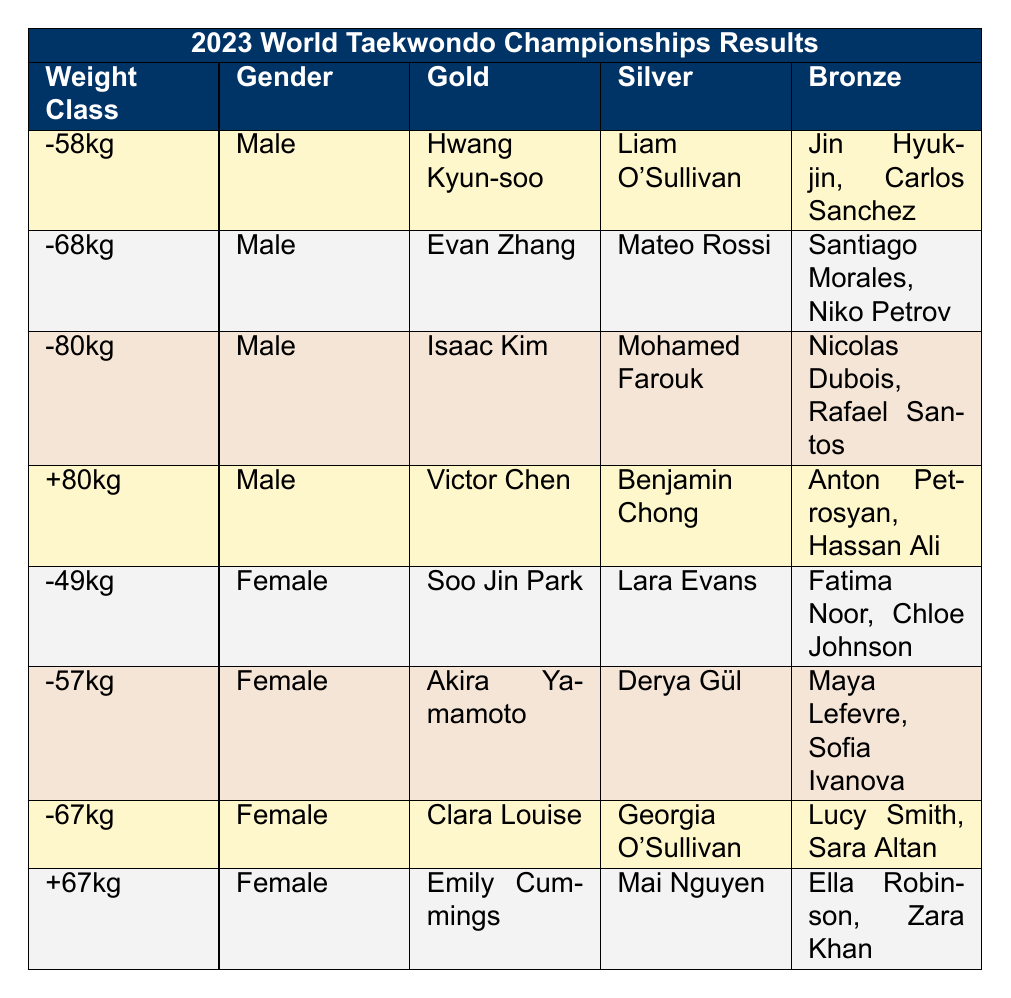What were the gold medalist names in the Women's -57kg weight class? The table lists the gold medalist for each weight class. For the Women's -57kg category, the gold medalist is Akira Yamamoto.
Answer: Akira Yamamoto How many female athletes won medals in the 2023 championships? To find the total number of female medalists, we can look at the number of medalists in each of the four women's weight classes. Each class has one gold, one silver, and two bronze medalists, resulting in a total of 4 (gold + silver + bronze) x 4 (categories) = 16 female medalists.
Answer: 16 Did any female athlete win a medal in both the Women's -49kg and Women's -57kg weight classes? To determine this, we look at the medalists listed in each weight class. The Women's -49kg gold medalist is Soo Jin Park, and the Women's -57kg gold medalist is Akira Yamamoto. No athlete appears in both categories, so the answer is no.
Answer: No Who was the silver medalist in the Men's +80kg weight class? Referring to the table, the silver medalist in the Men's +80kg category is Benjamin Chong.
Answer: Benjamin Chong What is the combined total of gold medals won by male athletes in the -58kg and -68kg weight classes? The gold medalists in the respective classes are Hwang Kyun-soo for -58kg and Evan Zhang for -68kg. We only need to count the male athletes who won gold. Each weight class has one gold medal, so the total is 2 gold medals.
Answer: 2 